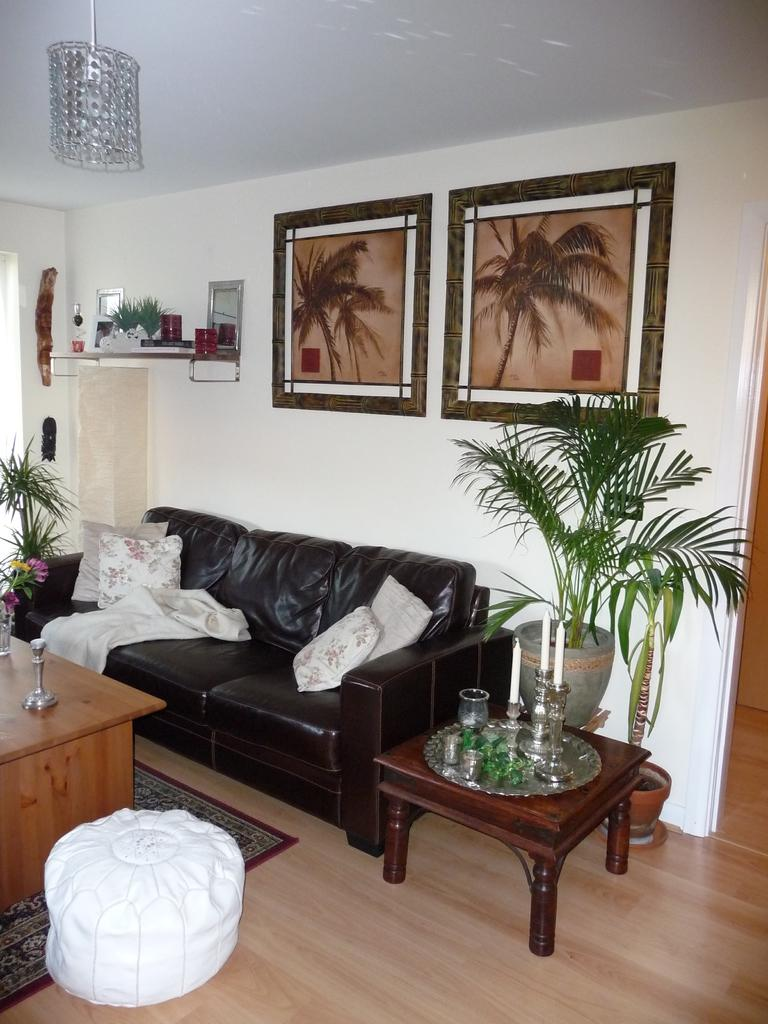What type of furniture is in the image? There is a sofa in the image. What is on the sofa? There are cushions on the sofa. What else can be seen in the image besides the sofa and cushions? There are plants visible in the image. What is on the plate in the image? There is a plate with stuffs in the image. What is hanging on the wall in the image? There are two frames on the wall in the image. What color is the sweater worn by the plant in the image? There is no sweater worn by the plant in the image, as plants do not wear clothing. 